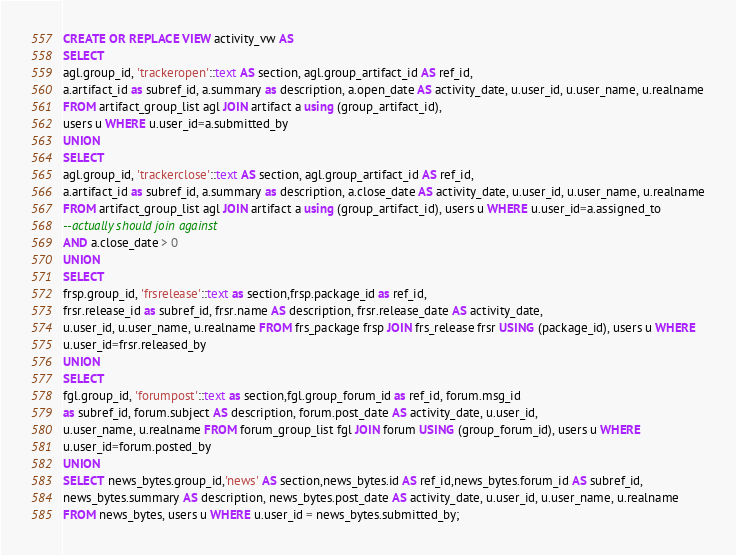<code> <loc_0><loc_0><loc_500><loc_500><_SQL_>CREATE OR REPLACE VIEW activity_vw AS
SELECT
agl.group_id, 'trackeropen'::text AS section, agl.group_artifact_id AS ref_id,
a.artifact_id as subref_id, a.summary as description, a.open_date AS activity_date, u.user_id, u.user_name, u.realname
FROM artifact_group_list agl JOIN artifact a using (group_artifact_id),
users u WHERE u.user_id=a.submitted_by
UNION
SELECT
agl.group_id, 'trackerclose'::text AS section, agl.group_artifact_id AS ref_id,
a.artifact_id as subref_id, a.summary as description, a.close_date AS activity_date, u.user_id, u.user_name, u.realname
FROM artifact_group_list agl JOIN artifact a using (group_artifact_id), users u WHERE u.user_id=a.assigned_to
--actually should join against
AND a.close_date > 0
UNION
SELECT
frsp.group_id, 'frsrelease'::text as section,frsp.package_id as ref_id,
frsr.release_id as subref_id, frsr.name AS description, frsr.release_date AS activity_date,
u.user_id, u.user_name, u.realname FROM frs_package frsp JOIN frs_release frsr USING (package_id), users u WHERE
u.user_id=frsr.released_by
UNION
SELECT
fgl.group_id, 'forumpost'::text as section,fgl.group_forum_id as ref_id, forum.msg_id
as subref_id, forum.subject AS description, forum.post_date AS activity_date, u.user_id,
u.user_name, u.realname FROM forum_group_list fgl JOIN forum USING (group_forum_id), users u WHERE
u.user_id=forum.posted_by
UNION
SELECT news_bytes.group_id,'news' AS section,news_bytes.id AS ref_id,news_bytes.forum_id AS subref_id,
news_bytes.summary AS description, news_bytes.post_date AS activity_date, u.user_id, u.user_name, u.realname
FROM news_bytes, users u WHERE u.user_id = news_bytes.submitted_by;
</code> 